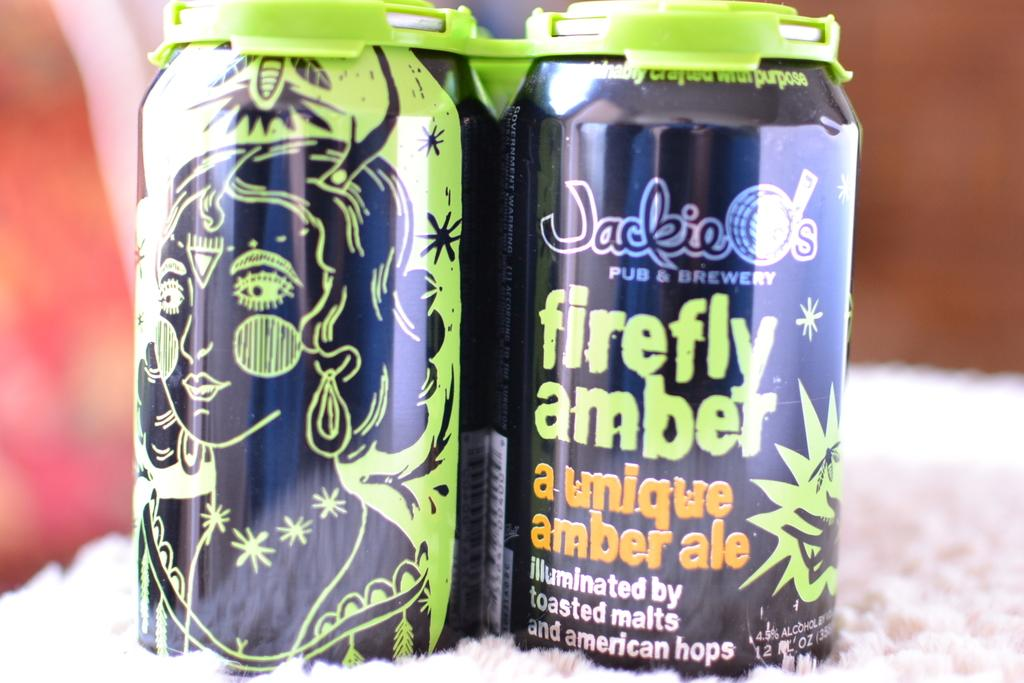Provide a one-sentence caption for the provided image. Two purple and green cans of Jackie O's Firefly Amber ale. 